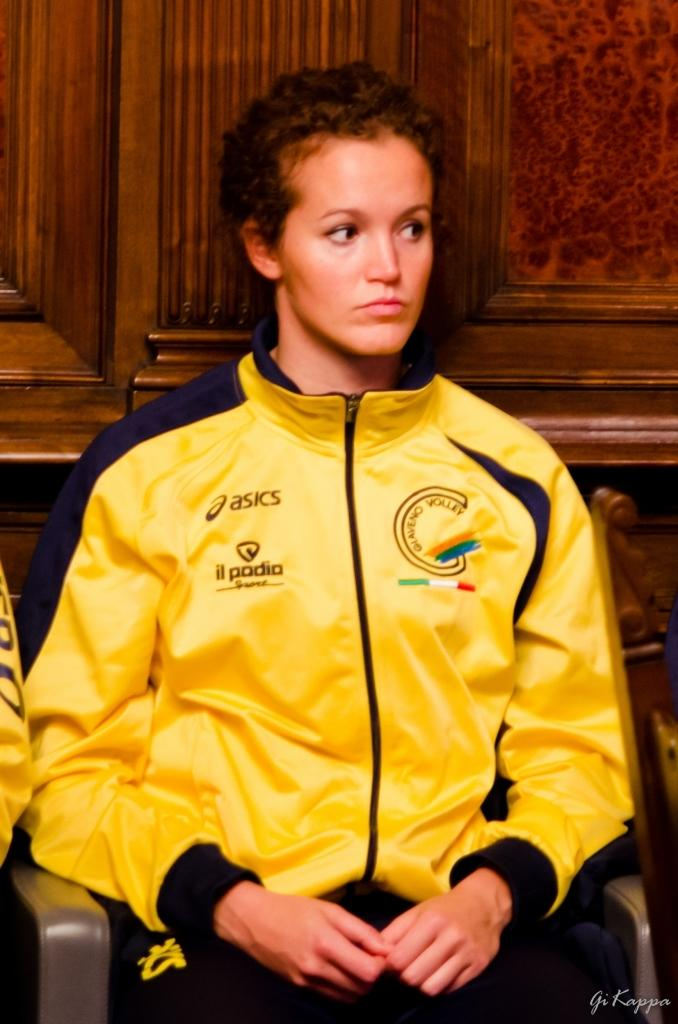<image>
Describe the image concisely. Woman wearing a yellow jersey that says Asics on it. 